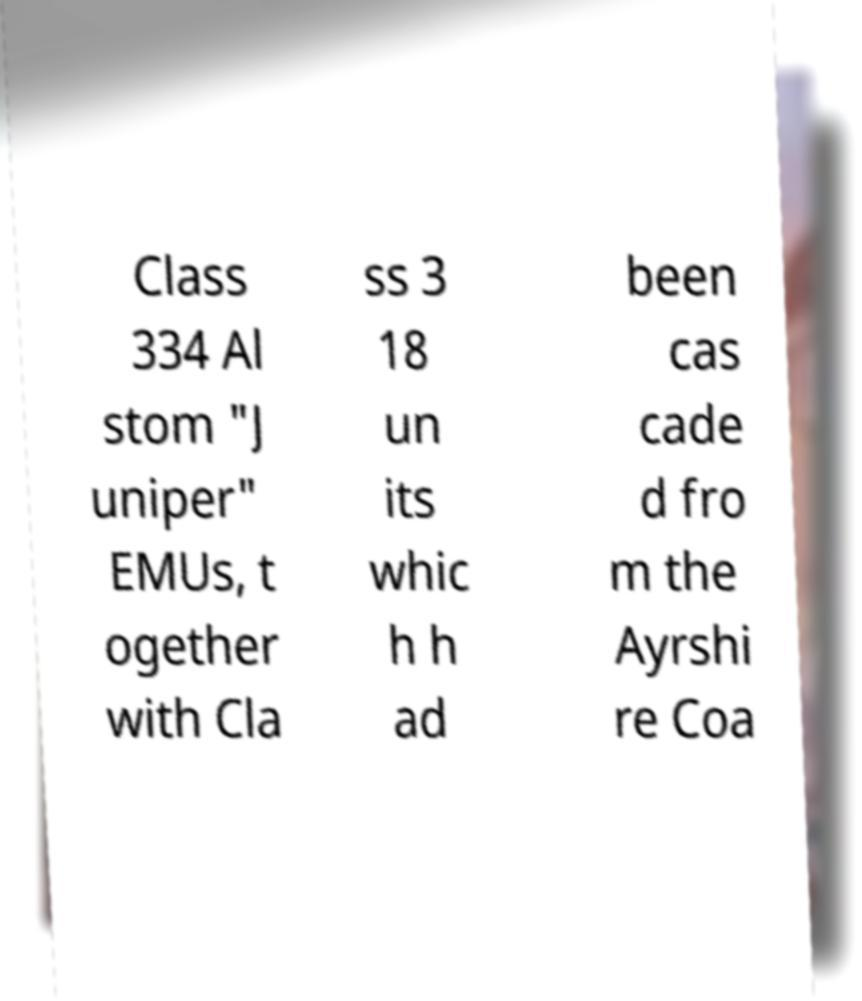Please read and relay the text visible in this image. What does it say? Class 334 Al stom "J uniper" EMUs, t ogether with Cla ss 3 18 un its whic h h ad been cas cade d fro m the Ayrshi re Coa 